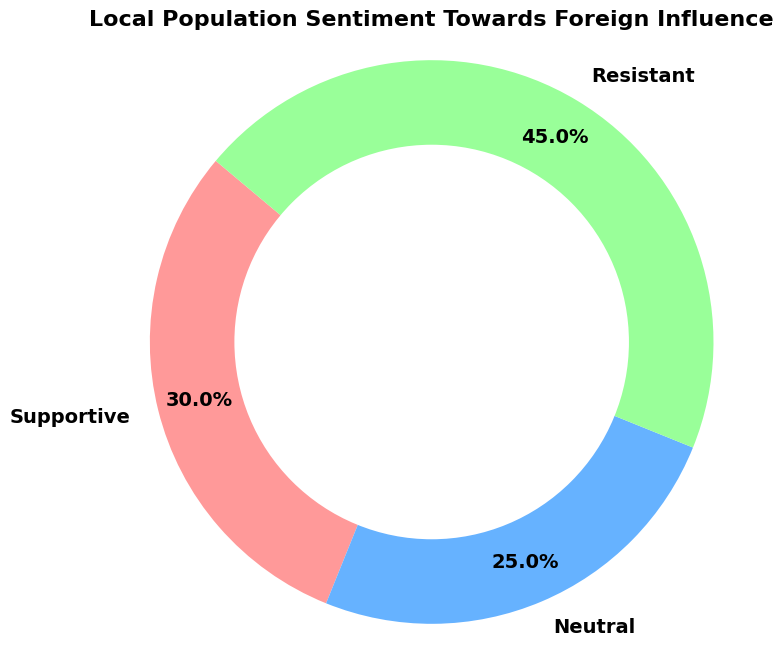What percentage of the local population is neutral towards foreign influence? The neutral section is labeled with its percentage on the chart. The percentage shown is 25%.
Answer: 25% How many percentage points more is the resistant sentiment compared to the supportive sentiment? Examine the chart for the percentages of resistant and supportive sentiments. The resistant sentiment is 45% and supportive is 30%. The difference is 45% - 30% = 15 percentage points.
Answer: 15 What is the total percentage of the supportive and neutral sentiments combined? Add the percentages of the supportive and neutral sentiments: 30% + 25% = 55%.
Answer: 55% Which sentiment has the smallest percentage in the ring chart? Compare the percentage values of supportive, neutral, and resistant sentiments. The smallest percentage is the neutral sentiment at 25%.
Answer: Neutral What is the percentage difference between the neutral and resistant sentiments? Look at the percentages labeled for neutral (25%) and resistant (45%) sentiments. Calculate the difference: 45% - 25% = 20%.
Answer: 20% Which sentiment category is represented by the green color in the chart? The chart uses specific colors for each sentiment category. The green color represents the resistant category, as observed from the legend.
Answer: Resistant Is the combined percentage of supportive and neutral sentiments greater than the resistant sentiment? Calculate the combined percentage of supportive (30%) and neutral (25%) sentiments: 30% + 25% = 55%. This is greater than the resistant sentiment at 45%.
Answer: Yes How much larger is the share of the resistant sentiment than the supportive sentiment? Subtract the supportive sentiment (30%) from the resistant sentiment (45%): 45% - 30% = 15%.
Answer: 15% What fraction of the local population is either supportive or resistant to foreign influence? Add the supportive (30%) and resistant (45%) sentiment percentages: 30% + 45% = 75%. Convert to a fraction: 75/100 = 3/4.
Answer: 3/4 